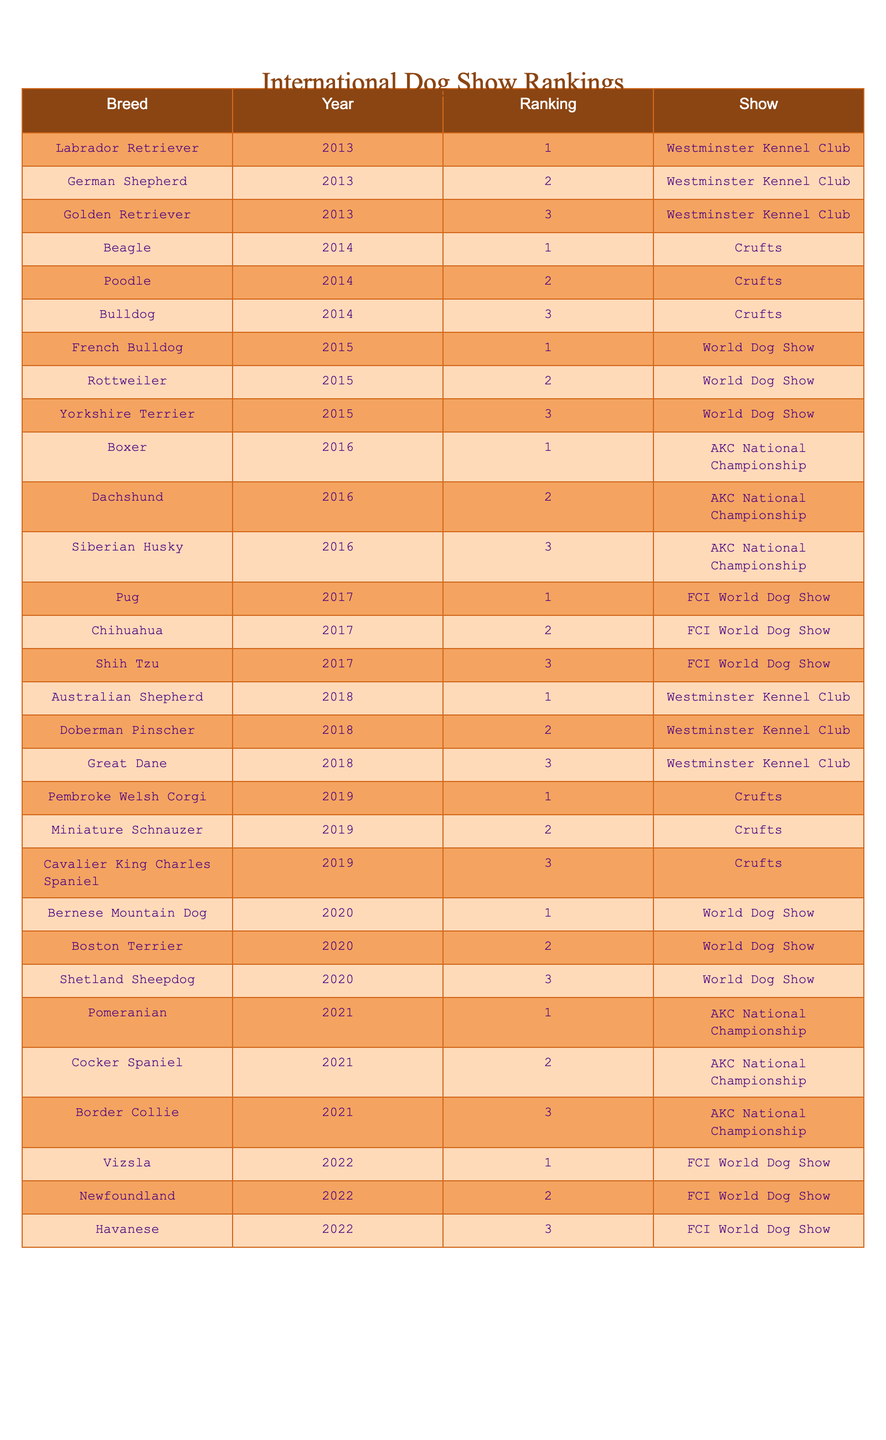What breed was ranked first at the Westminster Kennel Club in 2018? From the table, I can find the entries corresponding to the year 2018 and the event Westminster Kennel Club. In 2018, the first-ranked breed was the Australian Shepherd.
Answer: Australian Shepherd How many different breeds were ranked first in international dog shows over the years? By checking the table, I count each unique breed that has a ranking of 1 across all years. The breeds are: Labrador Retriever, Beagle, French Bulldog, Boxer, Pug, Pembroke Welsh Corgi, Bernese Mountain Dog, Pomeranian, Vizsla, totaling 9 unique breeds that were ranked first.
Answer: 9 Which breed was consistently ranked among the top three in the AKC National Championship in 2021? Looking at the entry for the year 2021 in the AKC National Championship, I see that the Pomeranian was ranked first, the Cocker Spaniel was ranked second, and the Border Collie was ranked third. Therefore, all three were among the top three.
Answer: Yes What were the top three breeds in the World Dog Show in 2020? By searching the table for the World Dog Show in 2020, I find that the breeds in order were Bernese Mountain Dog (1), Boston Terrier (2), and Shetland Sheepdog (3).
Answer: Bernese Mountain Dog, Boston Terrier, Shetland Sheepdog How does the ranking for the Poodle in 2014 compare to the Poodle's ranking in subsequent years? The table shows that the Poodle was ranked second in Crufts in 2014. However, no Poodle is listed in the rankings for the years that follow, meaning it did not place in the top three after that year in the data provided.
Answer: The Poodle did not rank in subsequent years Which breed had the lowest ranking in the shows listed in 2015? To find the lowest ranking, I can examine the ranks for 2015 which include French Bulldog (1), Rottweiler (2), and Yorkshire Terrier (3). The breed with the lowest ranking is the Yorkshire Terrier with a rank of 3.
Answer: Yorkshire Terrier What is the average ranking of the Beagle over the years listed? The table shows that the Beagle was ranked first in 2014. Since it's the only entry, the average ranking for the Beagle is simply 1.
Answer: 1 Did any breeds appear in more than one event in the same year? Upon reviewing the table for duplicates in years for the same breed, there are no breeds that were listed in more than one event in the same year.
Answer: No In which year and show did the Border Collie achieve its highest ranking? The Border Collie was ranked third in 2021 during the AKC National Championship. Since it's the only appearance, that is also its highest ranking.
Answer: 2021, AKC National Championship What breeds were ranked third in each of the shows from 2013 to 2022? I can list the third-ranks found in the table for each year: 2013- Golden Retriever, 2014- Bulldog, 2015- Yorkshire Terrier, 2016- Siberian Husky, 2017- Shih Tzu, 2018- Great Dane, 2019- Cavalier King Charles Spaniel, 2020- Shetland Sheepdog, 2021- Border Collie, 2022- Havanese.
Answer: Golden Retriever, Bulldog, Yorkshire Terrier, Siberian Husky, Shih Tzu, Great Dane, Cavalier King Charles Spaniel, Shetland Sheepdog, Border Collie, Havanese 